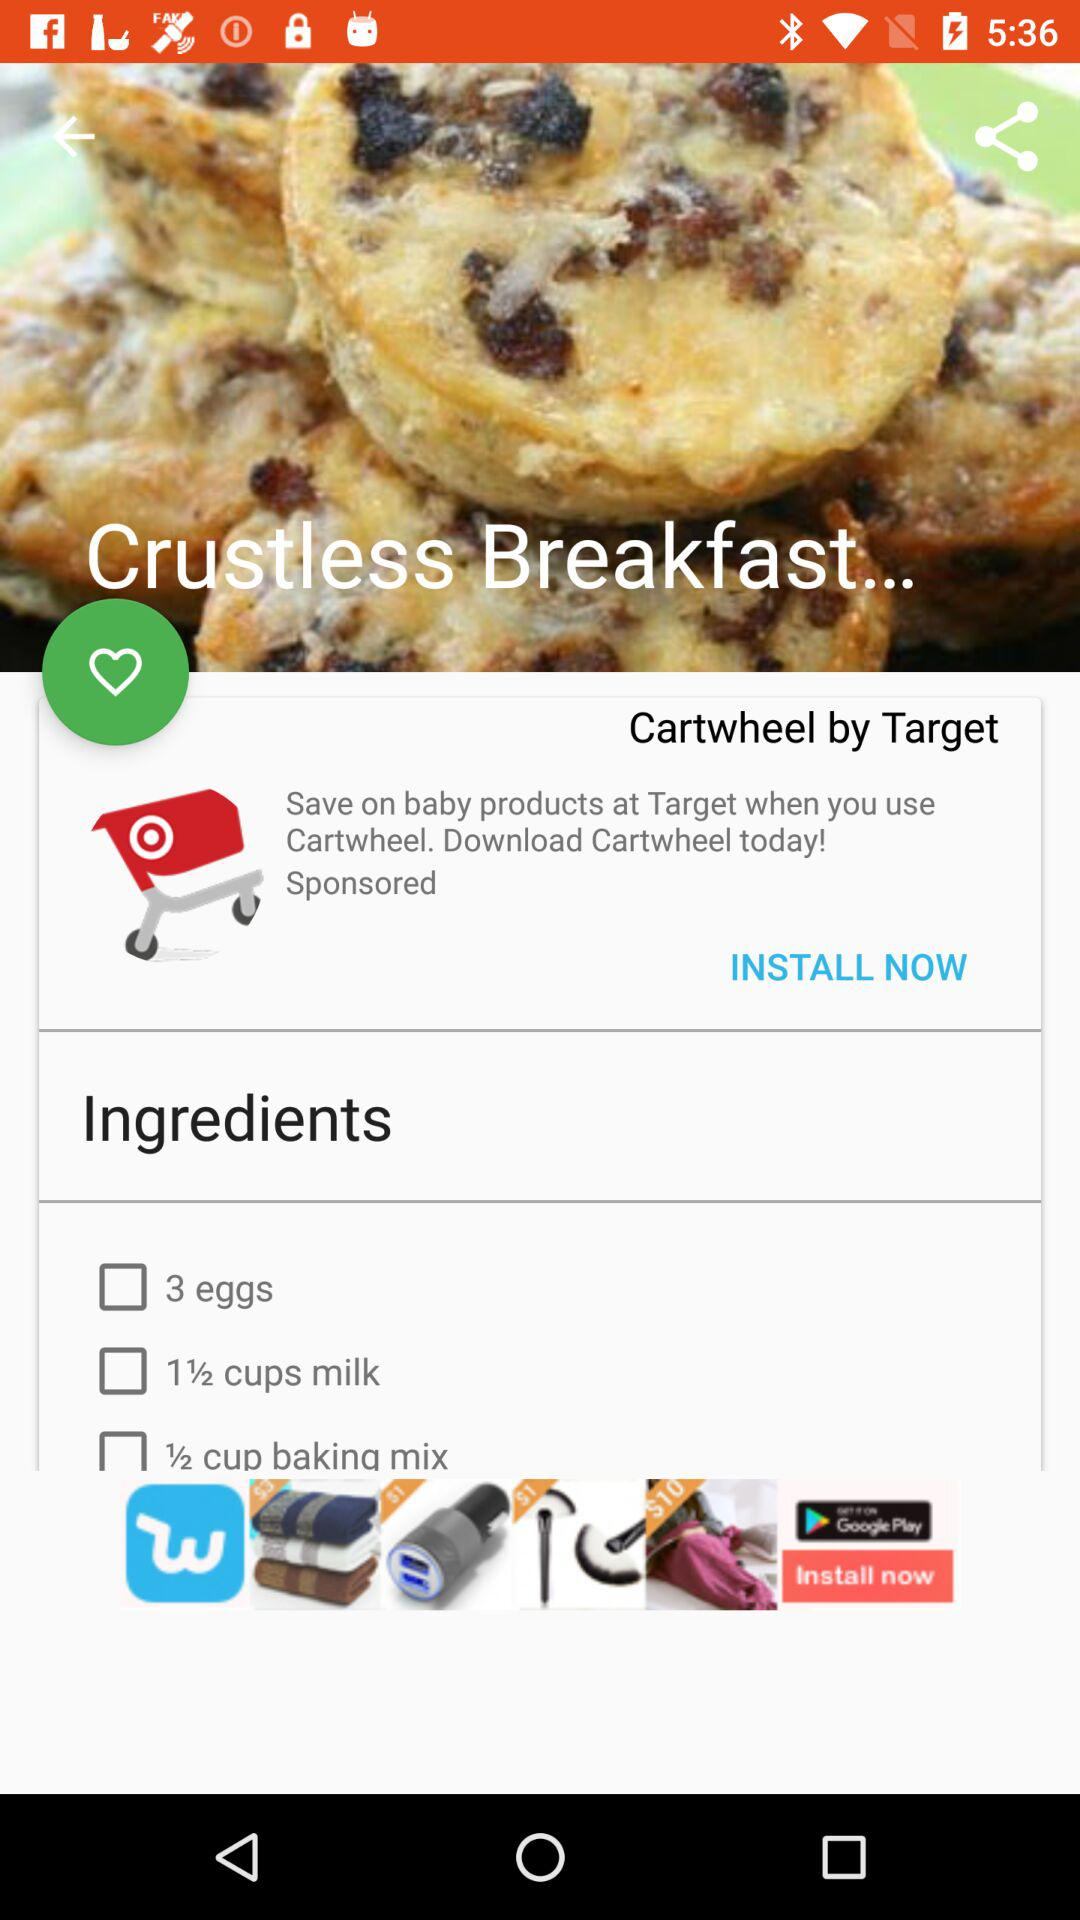What is the name of the dish? The name of the dish is "Crustless Breakfast...". 